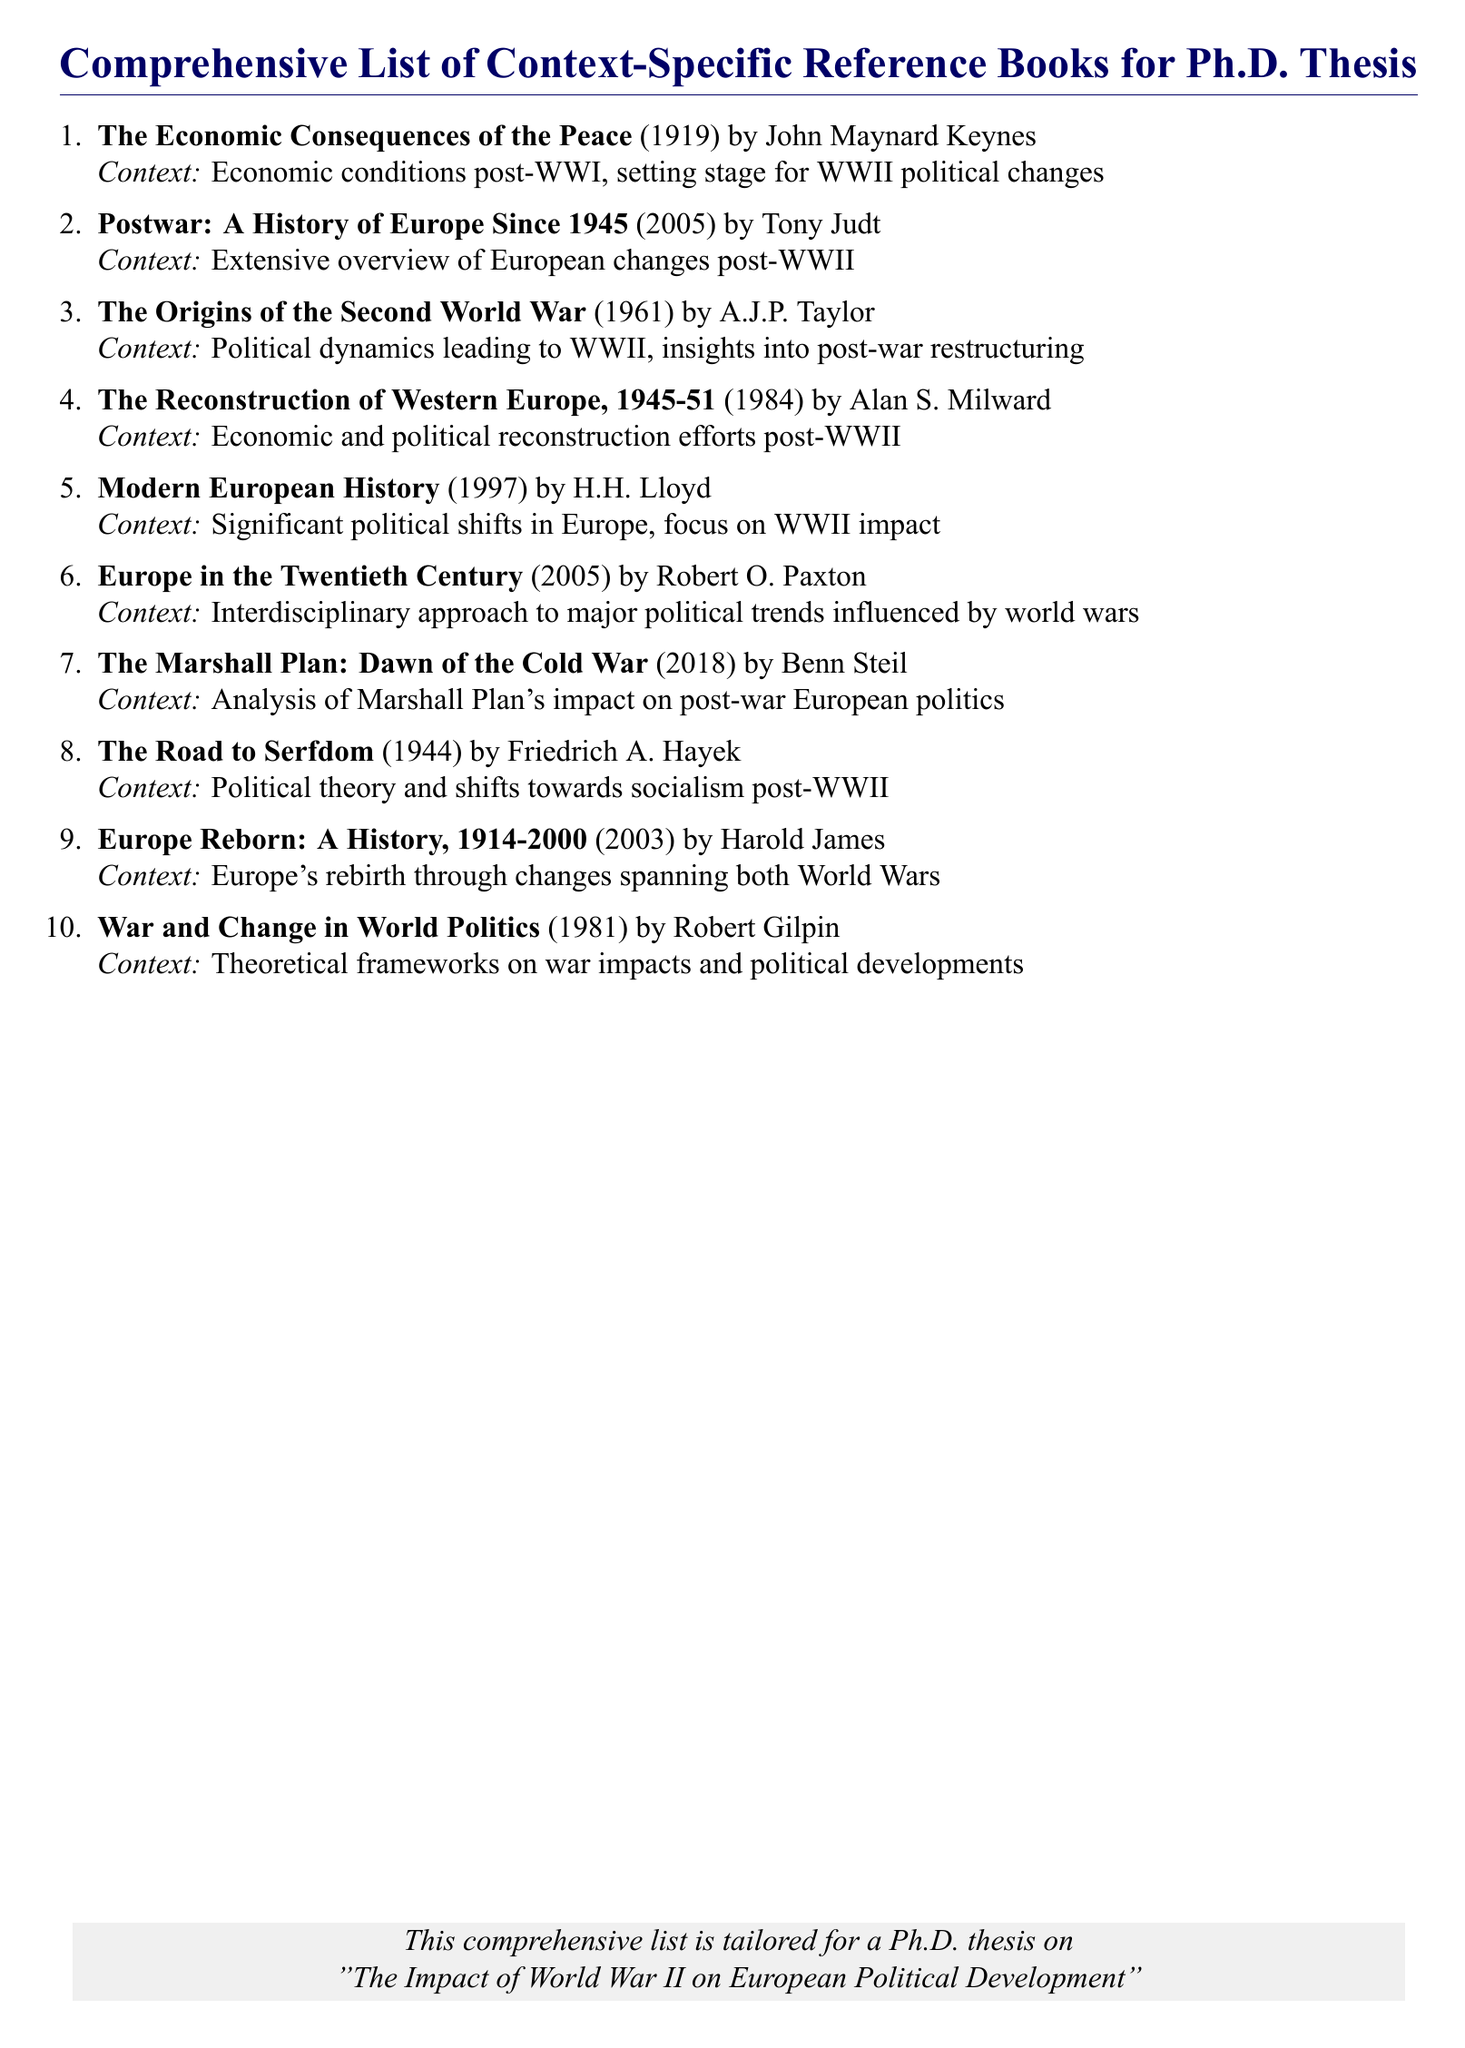What is the title of the book by John Maynard Keynes? The title is found in the detailed entry for Keynes which outlines his work on post-WWI economic conditions.
Answer: The Economic Consequences of the Peace Who authored the book "Postwar: A History of Europe Since 1945"? This information is provided in the author section of the respective book entry.
Answer: Tony Judt What year was "The Origins of the Second World War" published? The publication year is included in the entry for this title.
Answer: 1961 Which book discusses the Marshall Plan? The title is specified in the context related to the political development following WWII.
Answer: The Marshall Plan: Dawn of the Cold War How many reference books are listed in total? The number of items provided in the enumeration indicates the total count of books.
Answer: 10 What context is associated with "The Road to Serfdom"? This context can be found in the specific entry for Hayek’s book, detailing its focus on political theory post-WWII.
Answer: Political theory and shifts towards socialism post-WWII Which book addresses Europe’s history from 1914 to 2000? The answer can be found directly in the entry that mentions Europe's historical changes.
Answer: Europe Reborn: A History, 1914-2000 What theoretical aspect does "War and Change in World Politics" examine? This question pertains to the analytical focus given in the context of the Gilpin's book.
Answer: Theoretical frameworks on war impacts and political developments 